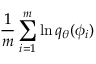<formula> <loc_0><loc_0><loc_500><loc_500>\frac { 1 } { m } \sum _ { i = 1 } ^ { m } \ln q _ { \theta } ( \phi _ { i } )</formula> 